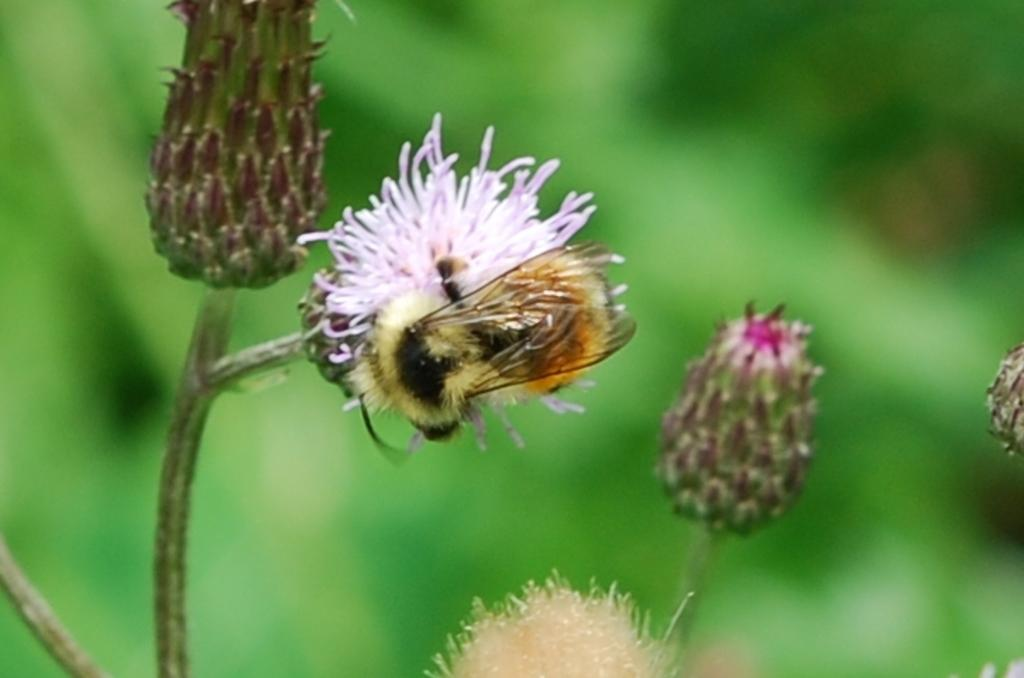What is the main subject of the image? There is a honey bee on a flower in the image. What type of plant is the honey bee interacting with? There are flowers with stems in the image. Can you describe the background of the image? The background of the image has a blurred view. How many birds are using the ear in the image? There are no birds or ears present in the image. 